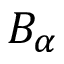Convert formula to latex. <formula><loc_0><loc_0><loc_500><loc_500>B _ { \alpha }</formula> 